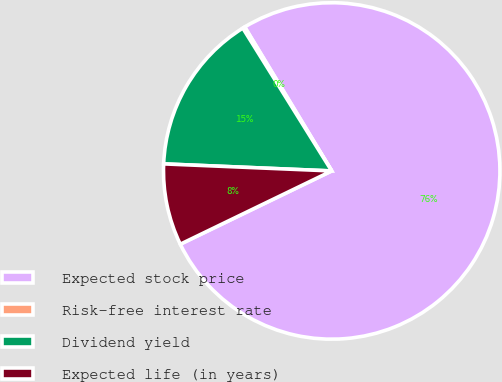Convert chart to OTSL. <chart><loc_0><loc_0><loc_500><loc_500><pie_chart><fcel>Expected stock price<fcel>Risk-free interest rate<fcel>Dividend yield<fcel>Expected life (in years)<nl><fcel>76.48%<fcel>0.21%<fcel>15.47%<fcel>7.84%<nl></chart> 